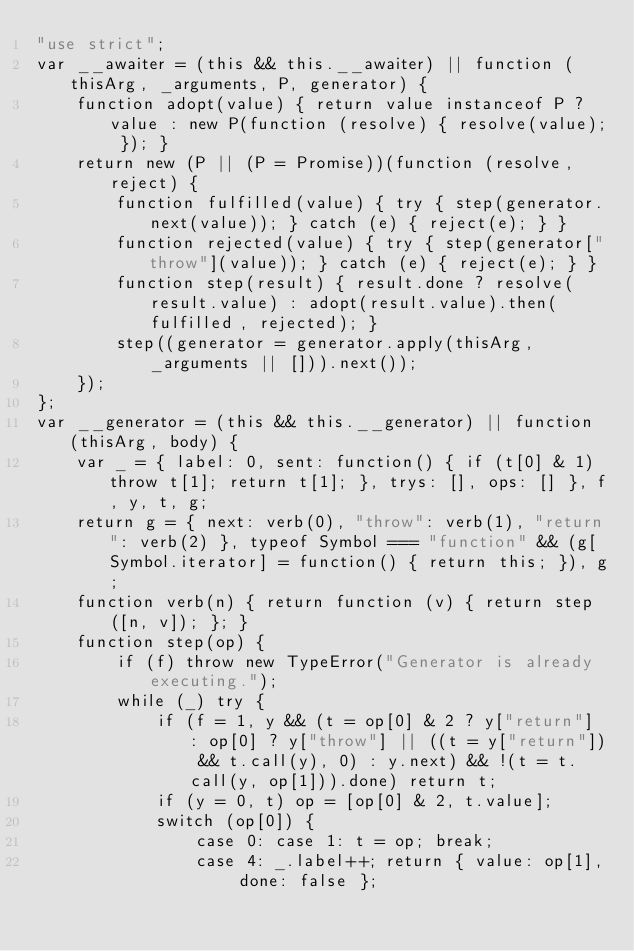Convert code to text. <code><loc_0><loc_0><loc_500><loc_500><_JavaScript_>"use strict";
var __awaiter = (this && this.__awaiter) || function (thisArg, _arguments, P, generator) {
    function adopt(value) { return value instanceof P ? value : new P(function (resolve) { resolve(value); }); }
    return new (P || (P = Promise))(function (resolve, reject) {
        function fulfilled(value) { try { step(generator.next(value)); } catch (e) { reject(e); } }
        function rejected(value) { try { step(generator["throw"](value)); } catch (e) { reject(e); } }
        function step(result) { result.done ? resolve(result.value) : adopt(result.value).then(fulfilled, rejected); }
        step((generator = generator.apply(thisArg, _arguments || [])).next());
    });
};
var __generator = (this && this.__generator) || function (thisArg, body) {
    var _ = { label: 0, sent: function() { if (t[0] & 1) throw t[1]; return t[1]; }, trys: [], ops: [] }, f, y, t, g;
    return g = { next: verb(0), "throw": verb(1), "return": verb(2) }, typeof Symbol === "function" && (g[Symbol.iterator] = function() { return this; }), g;
    function verb(n) { return function (v) { return step([n, v]); }; }
    function step(op) {
        if (f) throw new TypeError("Generator is already executing.");
        while (_) try {
            if (f = 1, y && (t = op[0] & 2 ? y["return"] : op[0] ? y["throw"] || ((t = y["return"]) && t.call(y), 0) : y.next) && !(t = t.call(y, op[1])).done) return t;
            if (y = 0, t) op = [op[0] & 2, t.value];
            switch (op[0]) {
                case 0: case 1: t = op; break;
                case 4: _.label++; return { value: op[1], done: false };</code> 